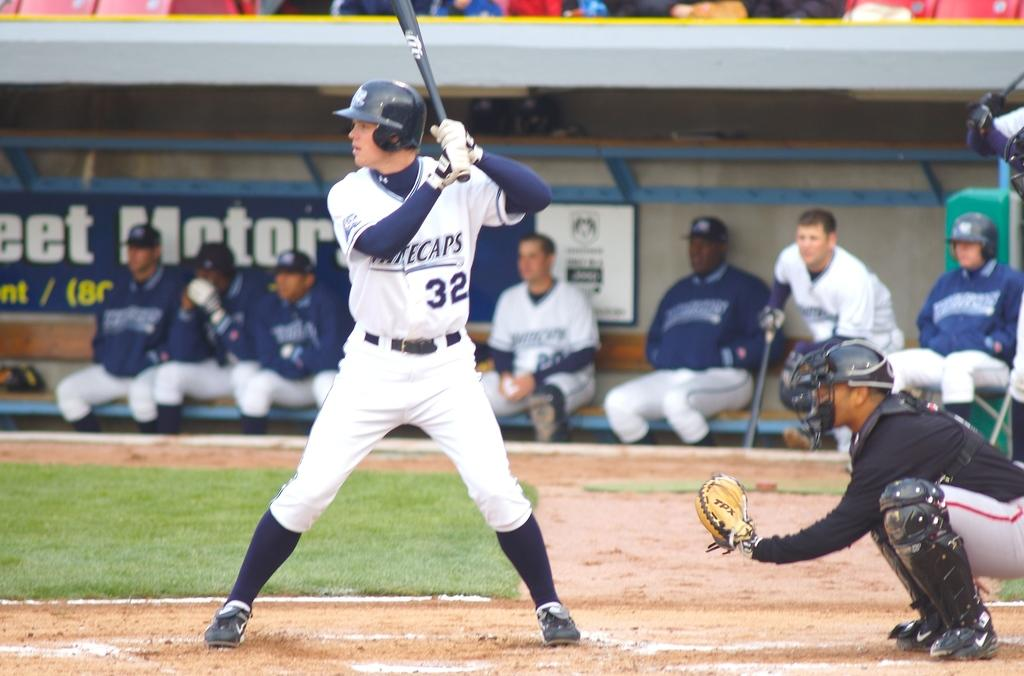Provide a one-sentence caption for the provided image. The west Michigan Whitecaps are up to bat. 